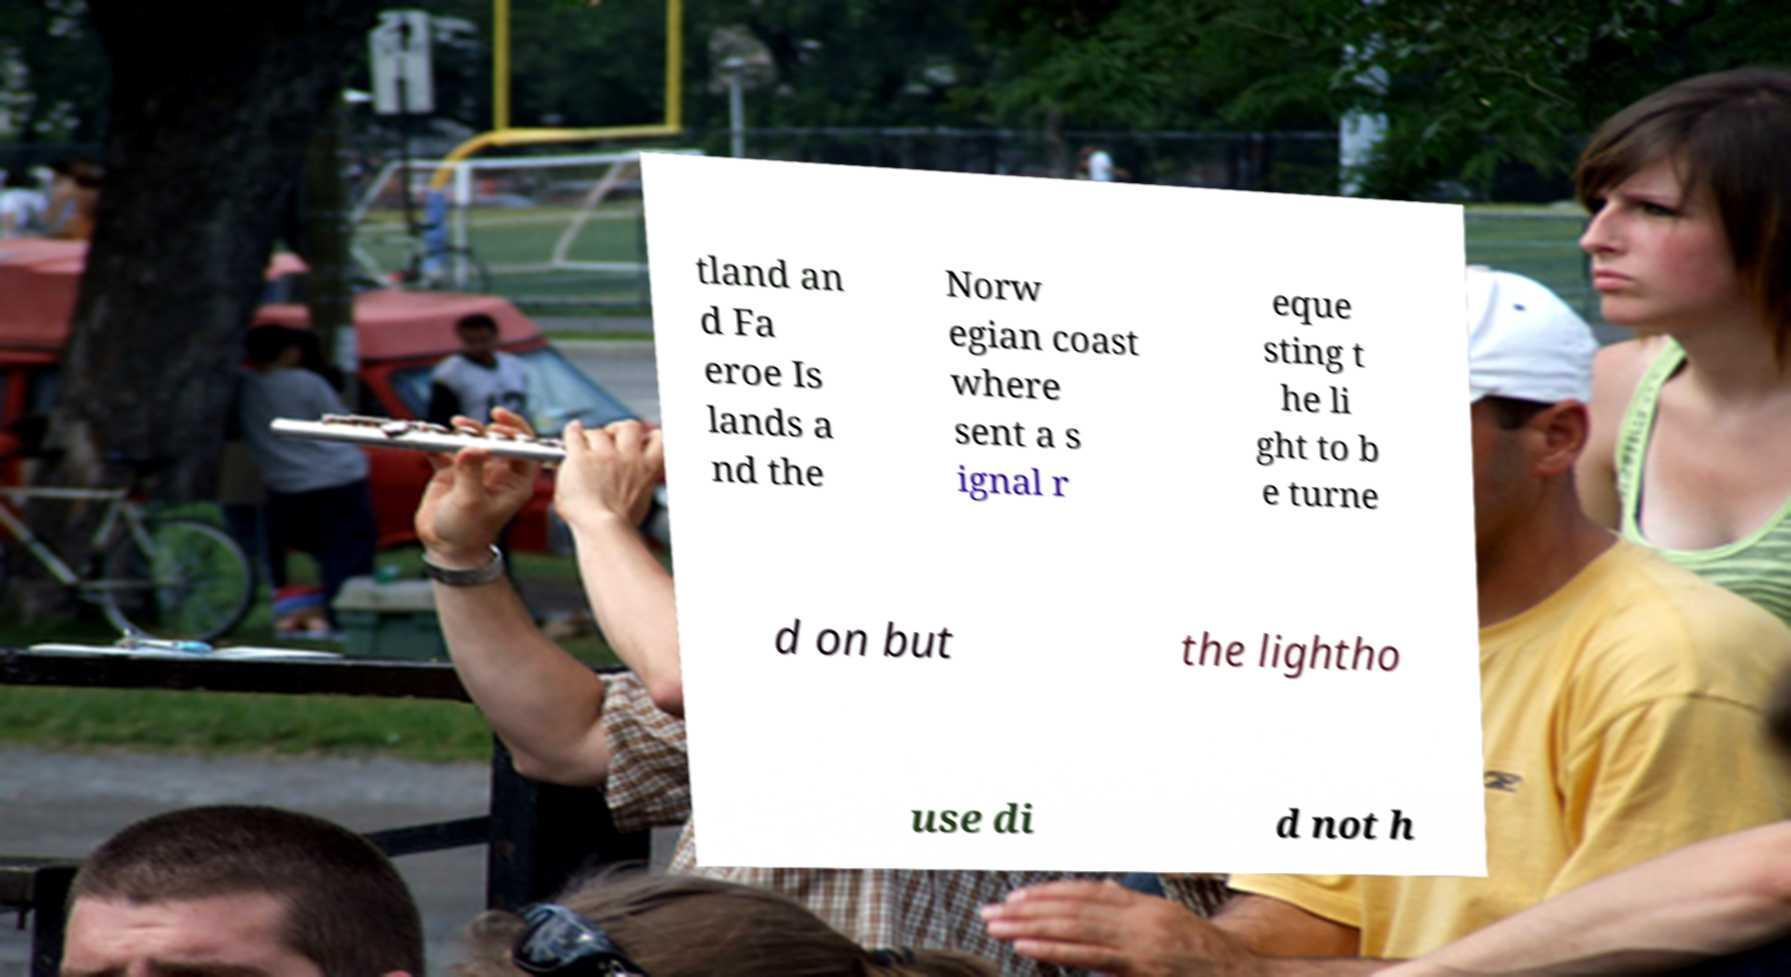Can you accurately transcribe the text from the provided image for me? tland an d Fa eroe Is lands a nd the Norw egian coast where sent a s ignal r eque sting t he li ght to b e turne d on but the lightho use di d not h 